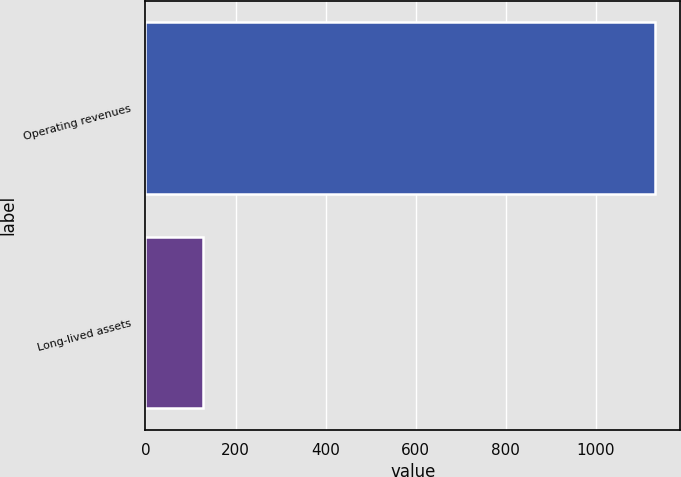Convert chart to OTSL. <chart><loc_0><loc_0><loc_500><loc_500><bar_chart><fcel>Operating revenues<fcel>Long-lived assets<nl><fcel>1131.6<fcel>127.2<nl></chart> 